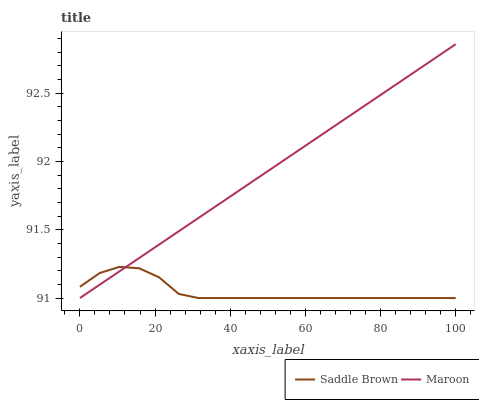Does Saddle Brown have the minimum area under the curve?
Answer yes or no. Yes. Does Maroon have the maximum area under the curve?
Answer yes or no. Yes. Does Maroon have the minimum area under the curve?
Answer yes or no. No. Is Maroon the smoothest?
Answer yes or no. Yes. Is Saddle Brown the roughest?
Answer yes or no. Yes. Is Maroon the roughest?
Answer yes or no. No. Does Saddle Brown have the lowest value?
Answer yes or no. Yes. Does Maroon have the highest value?
Answer yes or no. Yes. Does Maroon intersect Saddle Brown?
Answer yes or no. Yes. Is Maroon less than Saddle Brown?
Answer yes or no. No. Is Maroon greater than Saddle Brown?
Answer yes or no. No. 